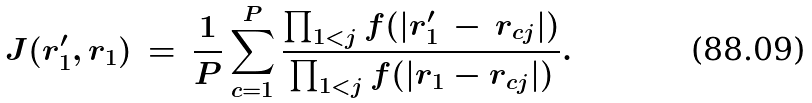<formula> <loc_0><loc_0><loc_500><loc_500>J ( r _ { 1 } ^ { \prime } , r _ { 1 } ) \, = \, \frac { 1 } { P } \sum _ { c = 1 } ^ { P } \frac { \prod _ { 1 < j } f ( | r _ { 1 } ^ { \prime } \, - \, r _ { c j } | ) } { \prod _ { 1 < j } f ( | r _ { 1 } - r _ { c j } | ) } .</formula> 